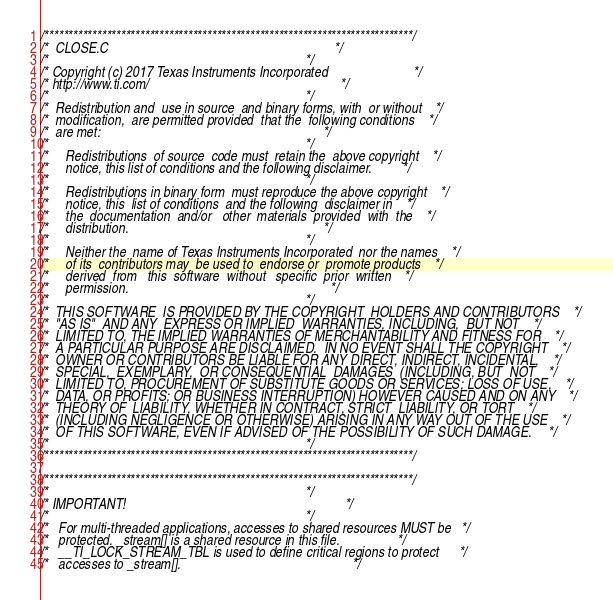Convert code to text. <code><loc_0><loc_0><loc_500><loc_500><_C_>/*****************************************************************************/
/*  CLOSE.C                                                                  */
/*                                                                           */
/* Copyright (c) 2017 Texas Instruments Incorporated                         */
/* http://www.ti.com/                                                        */
/*                                                                           */
/*  Redistribution and  use in source  and binary forms, with  or without    */
/*  modification,  are permitted provided  that the  following conditions    */
/*  are met:                                                                 */
/*                                                                           */
/*     Redistributions  of source  code must  retain the  above copyright    */
/*     notice, this list of conditions and the following disclaimer.         */
/*                                                                           */
/*     Redistributions in binary form  must reproduce the above copyright    */
/*     notice, this  list of conditions  and the following  disclaimer in    */
/*     the  documentation  and/or   other  materials  provided  with  the    */
/*     distribution.                                                         */
/*                                                                           */
/*     Neither the  name of Texas Instruments Incorporated  nor the names    */
/*     of its  contributors may  be used to  endorse or  promote products    */
/*     derived  from   this  software  without   specific  prior  written    */
/*     permission.                                                           */
/*                                                                           */
/*  THIS SOFTWARE  IS PROVIDED BY THE COPYRIGHT  HOLDERS AND CONTRIBUTORS    */
/*  "AS IS"  AND ANY  EXPRESS OR IMPLIED  WARRANTIES, INCLUDING,  BUT NOT    */
/*  LIMITED TO, THE IMPLIED WARRANTIES OF MERCHANTABILITY AND FITNESS FOR    */
/*  A PARTICULAR PURPOSE ARE DISCLAIMED.  IN NO EVENT SHALL THE COPYRIGHT    */
/*  OWNER OR CONTRIBUTORS BE LIABLE FOR ANY DIRECT, INDIRECT, INCIDENTAL,    */
/*  SPECIAL,  EXEMPLARY,  OR CONSEQUENTIAL  DAMAGES  (INCLUDING, BUT  NOT    */
/*  LIMITED TO, PROCUREMENT OF SUBSTITUTE GOODS OR SERVICES; LOSS OF USE,    */
/*  DATA, OR PROFITS; OR BUSINESS INTERRUPTION) HOWEVER CAUSED AND ON ANY    */
/*  THEORY OF  LIABILITY, WHETHER IN CONTRACT, STRICT  LIABILITY, OR TORT    */
/*  (INCLUDING NEGLIGENCE OR OTHERWISE) ARISING IN ANY WAY OUT OF THE USE    */
/*  OF THIS SOFTWARE, EVEN IF ADVISED OF THE POSSIBILITY OF SUCH DAMAGE.     */
/*                                                                           */
/*****************************************************************************/

/*****************************************************************************/
/*                                                                           */
/* IMPORTANT!                                                                */
/*                                                                           */
/*   For multi-threaded applications, accesses to shared resources MUST be   */
/*   protected. _stream[] is a shared resource in this file.                 */
/*   __TI_LOCK_STREAM_TBL is used to define critical regions to protect      */
/*   accesses to _stream[].                                                  */</code> 